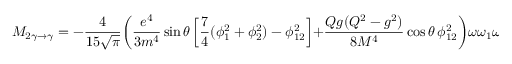Convert formula to latex. <formula><loc_0><loc_0><loc_500><loc_500>M _ { 2 \gamma \to \gamma } = - \frac { 4 } { 1 5 \sqrt { \pi } } \left ( \frac { e ^ { 4 } } { 3 m ^ { 4 } } \sin \theta \left [ \frac { 7 } { 4 } ( \phi _ { 1 } ^ { 2 } + \phi _ { 2 } ^ { 2 } ) - \phi _ { 1 2 } ^ { 2 } \right ] + \frac { Q g ( Q ^ { 2 } - g ^ { 2 } ) } { 8 M ^ { 4 } } \cos \theta \, \phi _ { 1 2 } ^ { 2 } \right ) \omega \omega _ { 1 } \omega _ { 2 } H \cos 2 \beta</formula> 